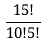Convert formula to latex. <formula><loc_0><loc_0><loc_500><loc_500>\frac { 1 5 ! } { 1 0 ! 5 ! }</formula> 